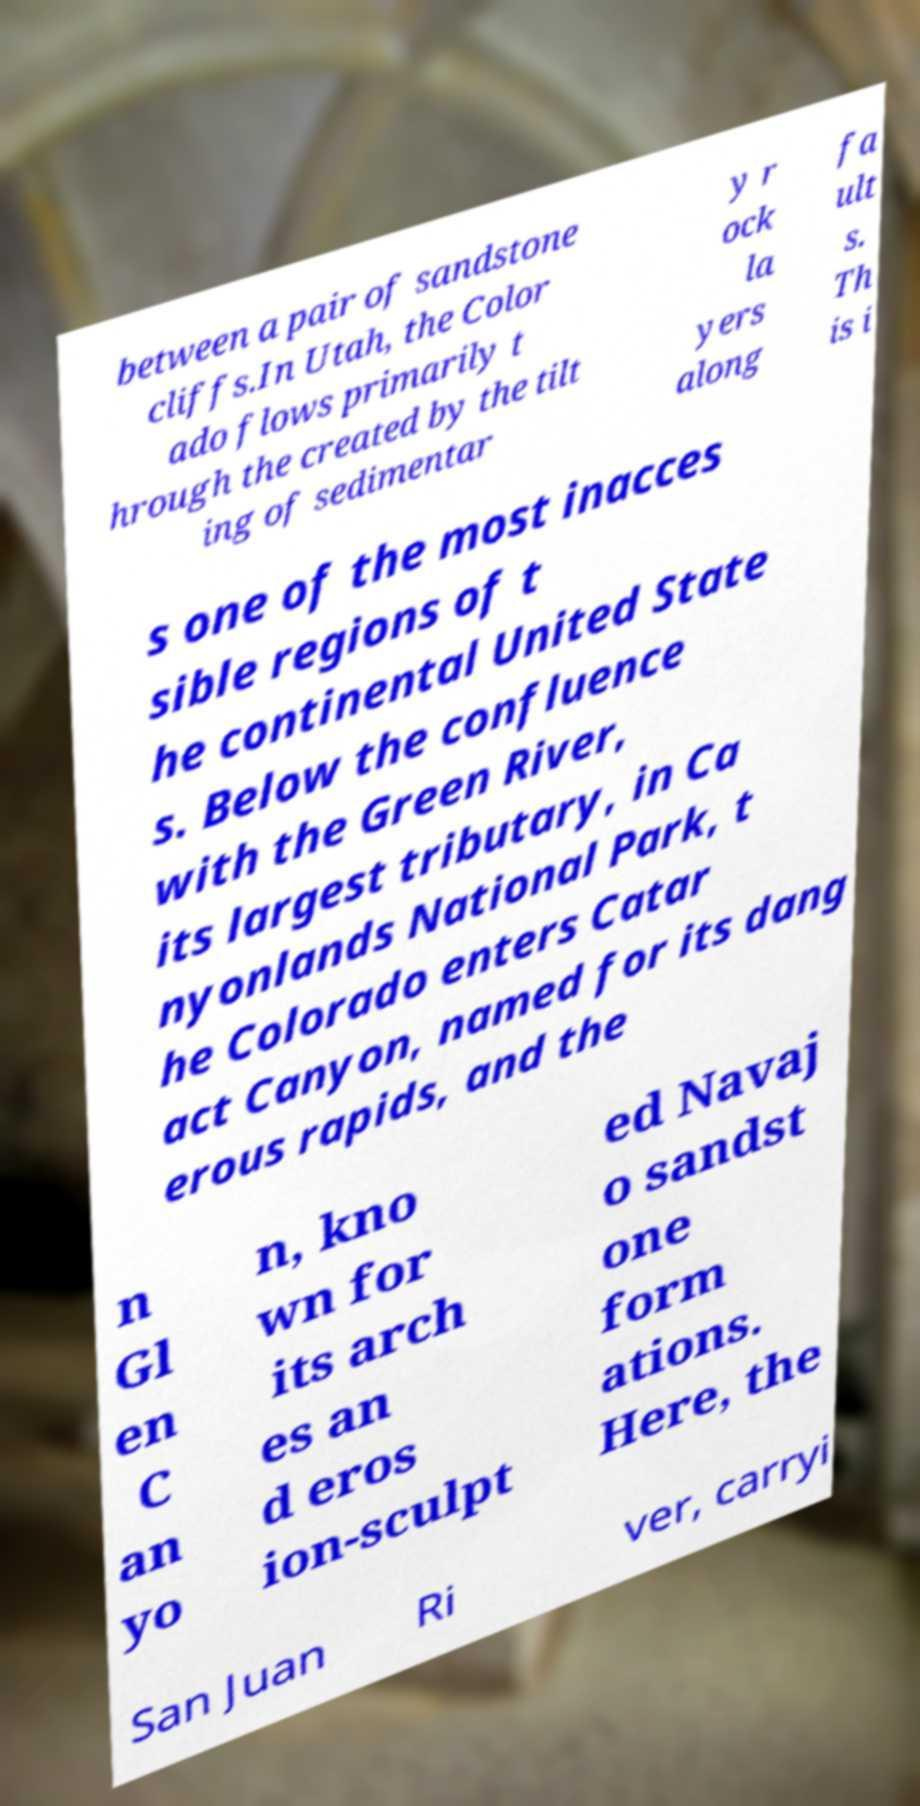Please read and relay the text visible in this image. What does it say? between a pair of sandstone cliffs.In Utah, the Color ado flows primarily t hrough the created by the tilt ing of sedimentar y r ock la yers along fa ult s. Th is i s one of the most inacces sible regions of t he continental United State s. Below the confluence with the Green River, its largest tributary, in Ca nyonlands National Park, t he Colorado enters Catar act Canyon, named for its dang erous rapids, and the n Gl en C an yo n, kno wn for its arch es an d eros ion-sculpt ed Navaj o sandst one form ations. Here, the San Juan Ri ver, carryi 